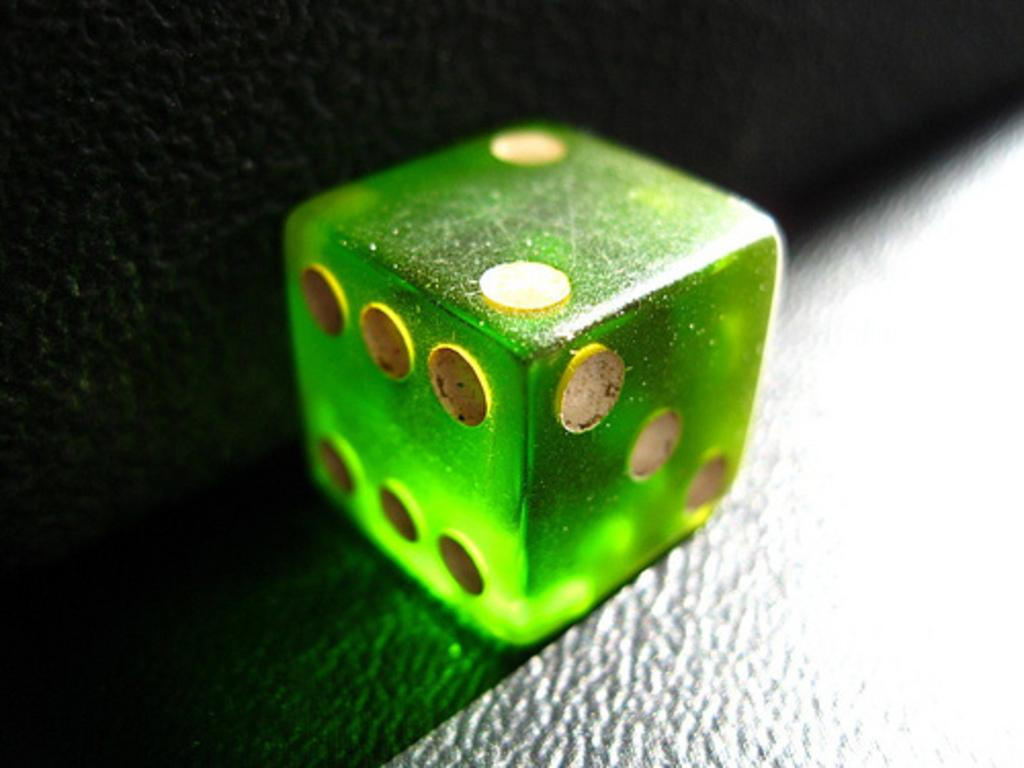What object is the main subject of the image? There is a dice in the image. What is the color of the surface on which the dice is placed? The dice is placed on a black surface. What year is depicted on the dice in the image? There is no year depicted on the dice in the image. What type of humor can be found in the image? There is no humor present in the image; it simply features a dice on a black surface. 